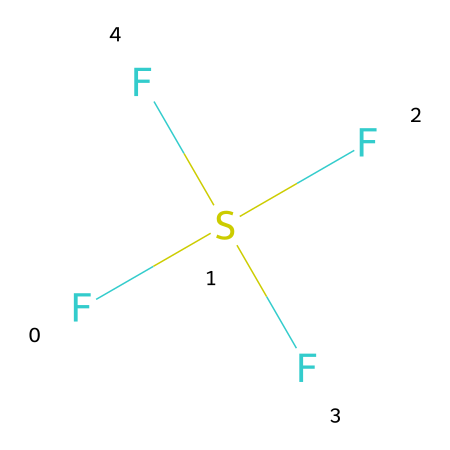What is the molecular formula of sulfur tetrafluoride? The molecular formula can be derived from the chemical structure by identifying the elements present and their counts. In this case, there are one sulfur (S) atom and four fluorine (F) atoms, giving the formula SF4.
Answer: SF4 How many valence electrons does sulfur have in sulfur tetrafluoride? Sulfur has six valence electrons in its ground state. This is consistent with its position in group 16 of the periodic table.
Answer: 6 What is the molecular geometry of sulfur tetrafluoride? To determine the molecular geometry, consider that sulfur tetrafluoride has a central sulfur atom with four fluorine atoms surrounding it. The arrangement of these atoms leads to a tetrahedral geometry due to the four bonding pairs of electrons.
Answer: tetrahedral What type of hybridization occurs in sulfur tetrafluoride? The hybridization can be deduced by considering the number of bonding pairs and lone pairs surrounding the sulfur atom. With four bonding pairs and no lone pairs, the hybridization is sp3.
Answer: sp3 Why is sulfur tetrafluoride considered a hypervalent compound? Hypervalency occurs when a central atom has more than eight electrons around it in its valence shell. In sulfur tetrafluoride, the sulfur atom is surrounded by four bonding pairs, leading to a total of 12 electrons, indicating hypervalency.
Answer: hypervalent Can sulfur tetrafluoride act as a Lewis acid? Lewis acids are species that can accept an electron pair. Given that sulfur in this compound has an empty d-orbital, it can accept electron pairs from potential Lewis bases.
Answer: yes 